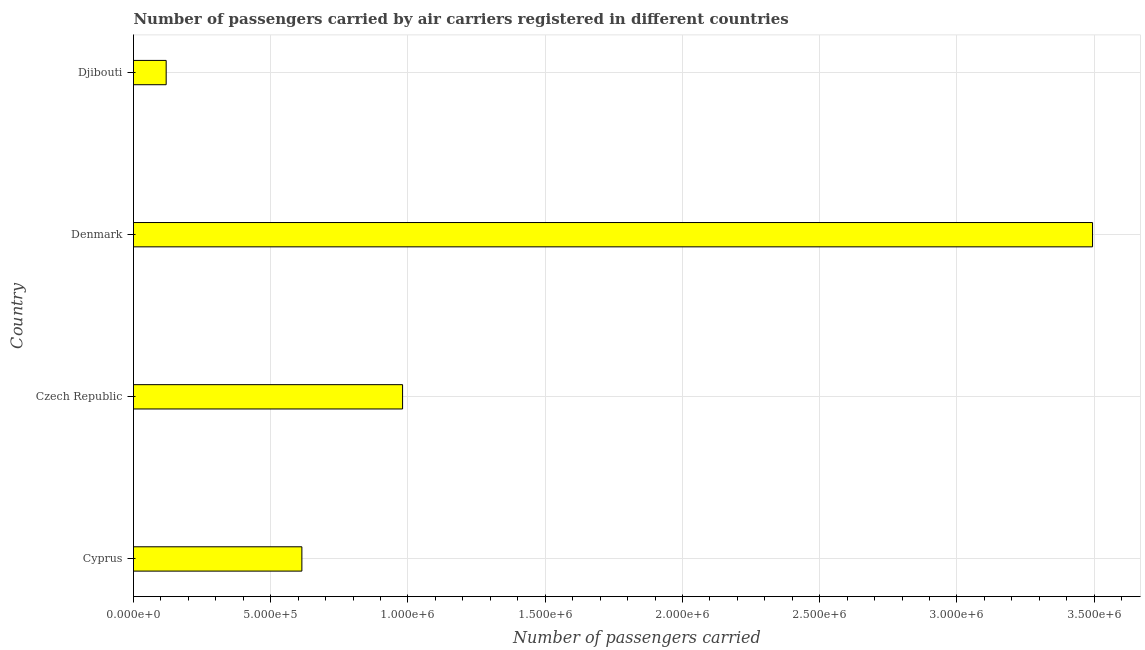Does the graph contain any zero values?
Keep it short and to the point. No. Does the graph contain grids?
Offer a very short reply. Yes. What is the title of the graph?
Provide a succinct answer. Number of passengers carried by air carriers registered in different countries. What is the label or title of the X-axis?
Make the answer very short. Number of passengers carried. What is the label or title of the Y-axis?
Make the answer very short. Country. What is the number of passengers carried in Cyprus?
Your answer should be very brief. 6.13e+05. Across all countries, what is the maximum number of passengers carried?
Your answer should be very brief. 3.49e+06. Across all countries, what is the minimum number of passengers carried?
Make the answer very short. 1.19e+05. In which country was the number of passengers carried maximum?
Provide a succinct answer. Denmark. In which country was the number of passengers carried minimum?
Ensure brevity in your answer.  Djibouti. What is the sum of the number of passengers carried?
Make the answer very short. 5.21e+06. What is the difference between the number of passengers carried in Czech Republic and Djibouti?
Provide a short and direct response. 8.61e+05. What is the average number of passengers carried per country?
Provide a succinct answer. 1.30e+06. What is the median number of passengers carried?
Give a very brief answer. 7.97e+05. What is the ratio of the number of passengers carried in Cyprus to that in Djibouti?
Offer a terse response. 5.16. Is the number of passengers carried in Czech Republic less than that in Denmark?
Give a very brief answer. Yes. What is the difference between the highest and the second highest number of passengers carried?
Your answer should be very brief. 2.51e+06. What is the difference between the highest and the lowest number of passengers carried?
Provide a short and direct response. 3.38e+06. Are all the bars in the graph horizontal?
Make the answer very short. Yes. Are the values on the major ticks of X-axis written in scientific E-notation?
Your answer should be very brief. Yes. What is the Number of passengers carried in Cyprus?
Make the answer very short. 6.13e+05. What is the Number of passengers carried in Czech Republic?
Offer a terse response. 9.80e+05. What is the Number of passengers carried in Denmark?
Make the answer very short. 3.49e+06. What is the Number of passengers carried of Djibouti?
Ensure brevity in your answer.  1.19e+05. What is the difference between the Number of passengers carried in Cyprus and Czech Republic?
Provide a succinct answer. -3.67e+05. What is the difference between the Number of passengers carried in Cyprus and Denmark?
Offer a very short reply. -2.88e+06. What is the difference between the Number of passengers carried in Cyprus and Djibouti?
Provide a succinct answer. 4.94e+05. What is the difference between the Number of passengers carried in Czech Republic and Denmark?
Your response must be concise. -2.51e+06. What is the difference between the Number of passengers carried in Czech Republic and Djibouti?
Your answer should be compact. 8.61e+05. What is the difference between the Number of passengers carried in Denmark and Djibouti?
Keep it short and to the point. 3.38e+06. What is the ratio of the Number of passengers carried in Cyprus to that in Czech Republic?
Your answer should be very brief. 0.63. What is the ratio of the Number of passengers carried in Cyprus to that in Denmark?
Ensure brevity in your answer.  0.18. What is the ratio of the Number of passengers carried in Cyprus to that in Djibouti?
Offer a terse response. 5.16. What is the ratio of the Number of passengers carried in Czech Republic to that in Denmark?
Give a very brief answer. 0.28. What is the ratio of the Number of passengers carried in Czech Republic to that in Djibouti?
Offer a terse response. 8.24. What is the ratio of the Number of passengers carried in Denmark to that in Djibouti?
Keep it short and to the point. 29.36. 